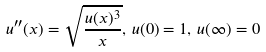<formula> <loc_0><loc_0><loc_500><loc_500>u ^ { \prime \prime } ( x ) = \sqrt { \frac { u ( x ) ^ { 3 } } { x } } , \, u ( 0 ) = 1 , \, u ( \infty ) = 0</formula> 